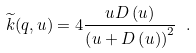<formula> <loc_0><loc_0><loc_500><loc_500>\widetilde { k } ( q , u ) = 4 \frac { u D \left ( u \right ) } { \left ( u + D \left ( u \right ) \right ) ^ { 2 } } \ .</formula> 